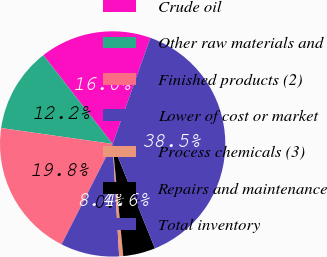Convert chart. <chart><loc_0><loc_0><loc_500><loc_500><pie_chart><fcel>Crude oil<fcel>Other raw materials and<fcel>Finished products (2)<fcel>Lower of cost or market<fcel>Process chemicals (3)<fcel>Repairs and maintenance<fcel>Total inventory<nl><fcel>15.98%<fcel>12.19%<fcel>19.77%<fcel>8.41%<fcel>0.58%<fcel>4.62%<fcel>38.45%<nl></chart> 